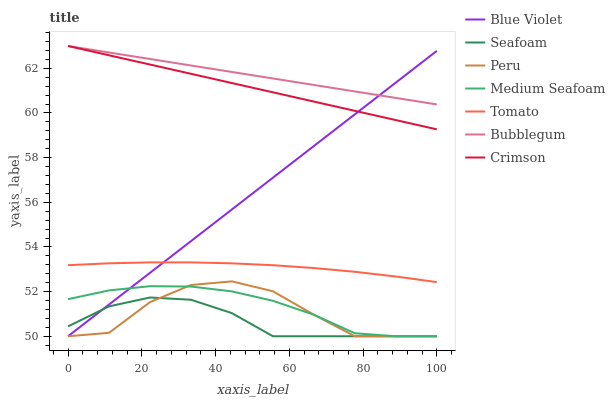Does Seafoam have the minimum area under the curve?
Answer yes or no. Yes. Does Bubblegum have the maximum area under the curve?
Answer yes or no. Yes. Does Bubblegum have the minimum area under the curve?
Answer yes or no. No. Does Seafoam have the maximum area under the curve?
Answer yes or no. No. Is Crimson the smoothest?
Answer yes or no. Yes. Is Peru the roughest?
Answer yes or no. Yes. Is Seafoam the smoothest?
Answer yes or no. No. Is Seafoam the roughest?
Answer yes or no. No. Does Bubblegum have the lowest value?
Answer yes or no. No. Does Crimson have the highest value?
Answer yes or no. Yes. Does Seafoam have the highest value?
Answer yes or no. No. Is Tomato less than Crimson?
Answer yes or no. Yes. Is Crimson greater than Seafoam?
Answer yes or no. Yes. Does Blue Violet intersect Medium Seafoam?
Answer yes or no. Yes. Is Blue Violet less than Medium Seafoam?
Answer yes or no. No. Is Blue Violet greater than Medium Seafoam?
Answer yes or no. No. Does Tomato intersect Crimson?
Answer yes or no. No. 